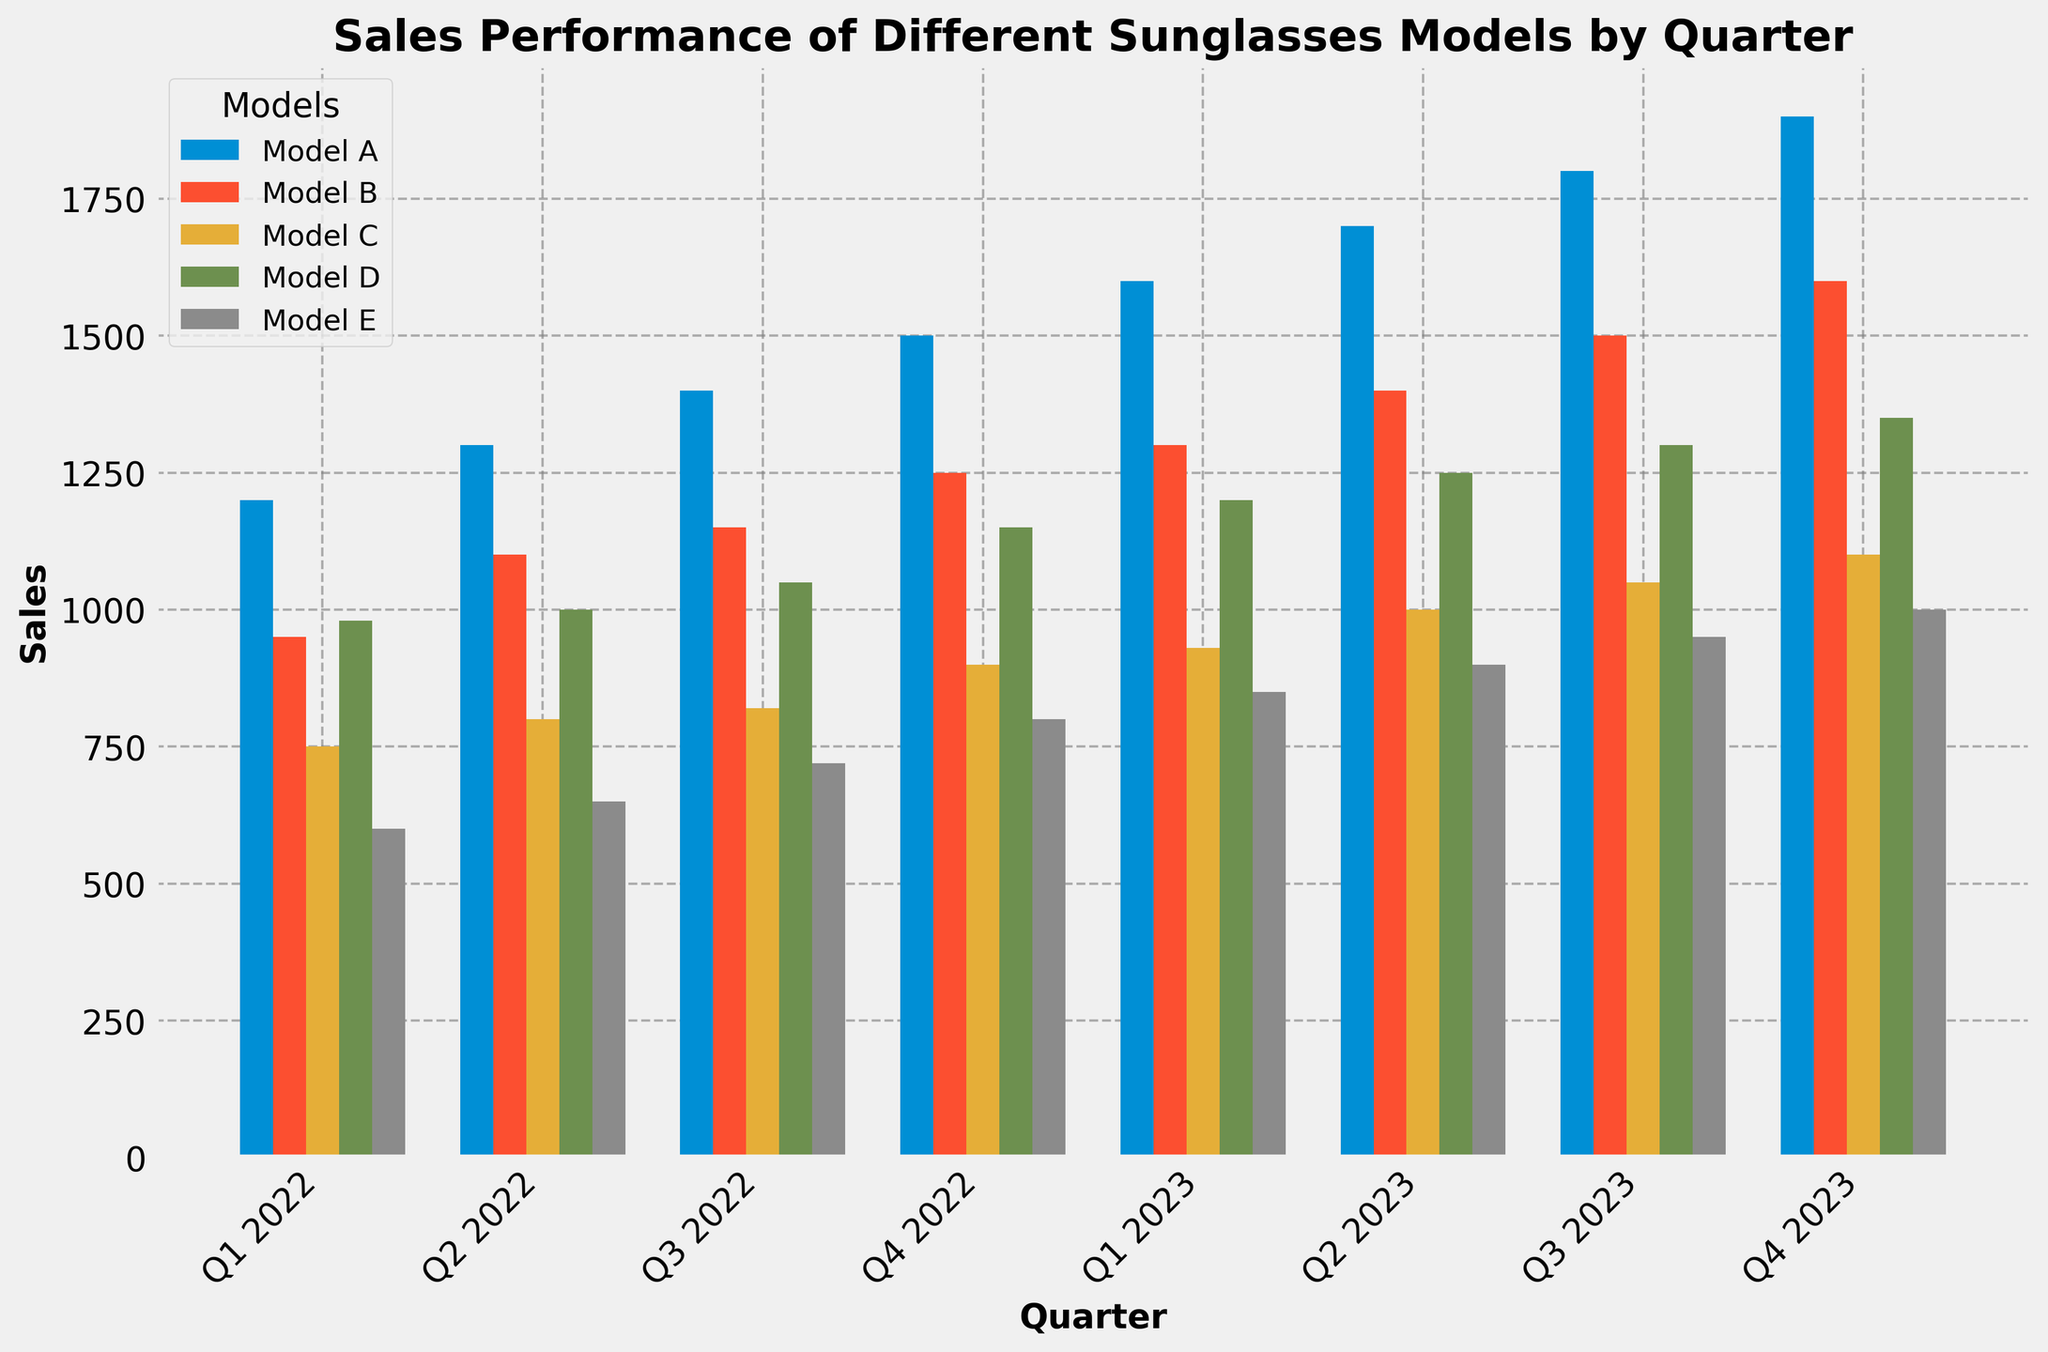What was the best-selling sunglasses model in Q4 2023? By visually inspecting the bar chart, observe which bar is the tallest in Q4 2023. The tallest bar corresponds to Model A.
Answer: Model A Which quarter showed the highest sales for Model C? Look at the bars representing Model C across all quarters and identify which bar is the tallest. The tallest bar is in Q4 2023.
Answer: Q4 2023 How did the sales for Model B change from Q1 2022 to Q4 2023? Compare the heights of the bars for Model B from Q1 2022 to Q4 2023. Sales increased from 950 to 1600.
Answer: Increased by 650 What was the total sales for Model E across all quarters in 2023? Add the heights of the bars for Model E in Q1, Q2, Q3, and Q4 of 2023: 850 + 900 + 950 + 1000 = 3700.
Answer: 3700 Which model had the smallest growth in sales from Q1 to Q4 2023? Calculate the difference in sales from Q1 to Q4 2023 for each model and find which one is the smallest. Model C grew from 930 to 1100, which is 170, the smallest growth.
Answer: Model C In which quarter did Model A and Model D have the same sales? Observe the bars for Model A and Model D in each quarter. They have the same height in Q1 2022, both at around 1200.
Answer: Q1 2022 Which quarter had the highest overall sales across all models? Sum the heights of the bars for all models in each quarter and compare. Q4 2023 has the highest overall sales.
Answer: Q4 2023 What was the average sales per quarter for Model B in 2023? Add the sales for Model B in each quarter of 2023 and divide by 4: (1300 + 1400 + 1500 + 1600) / 4 = 1450.
Answer: 1450 What was the percentage increase in sales for Model D from Q2 2022 to Q2 2023? Calculate the increase in sales and then find the percentage: (1250 - 1000) / 1000 * 100 = 25%.
Answer: 25% By how much did the sales for Model E increase from Q4 2022 to Q4 2023? Subtract the sales in Q4 2022 from sales in Q4 2023 for Model E: 1000 - 800 = 200.
Answer: 200 